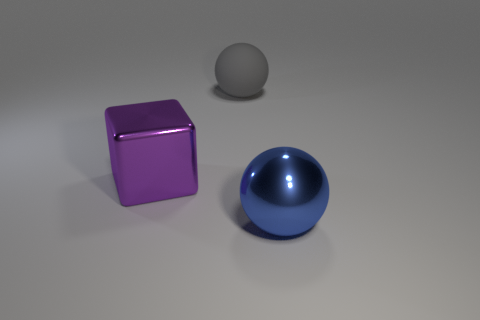Is there any other thing of the same color as the cube?
Offer a terse response. No. What number of balls are red rubber things or large gray things?
Offer a very short reply. 1. How many objects are on the right side of the purple metallic thing and in front of the large gray matte object?
Provide a succinct answer. 1. Are there an equal number of blue things in front of the large purple metal object and large purple metal things to the left of the big shiny sphere?
Provide a short and direct response. Yes. There is a shiny object to the right of the large purple block; is its shape the same as the big rubber thing?
Your answer should be compact. Yes. What is the shape of the metallic object to the right of the big thing that is behind the large shiny object to the left of the gray object?
Provide a short and direct response. Sphere. There is a big thing that is to the right of the metallic cube and behind the blue thing; what material is it?
Offer a very short reply. Rubber. Are there fewer large matte objects than spheres?
Keep it short and to the point. Yes. Do the gray thing and the large thing on the right side of the large rubber sphere have the same shape?
Provide a short and direct response. Yes. Do the metal object that is in front of the purple object and the purple shiny object have the same size?
Give a very brief answer. Yes. 